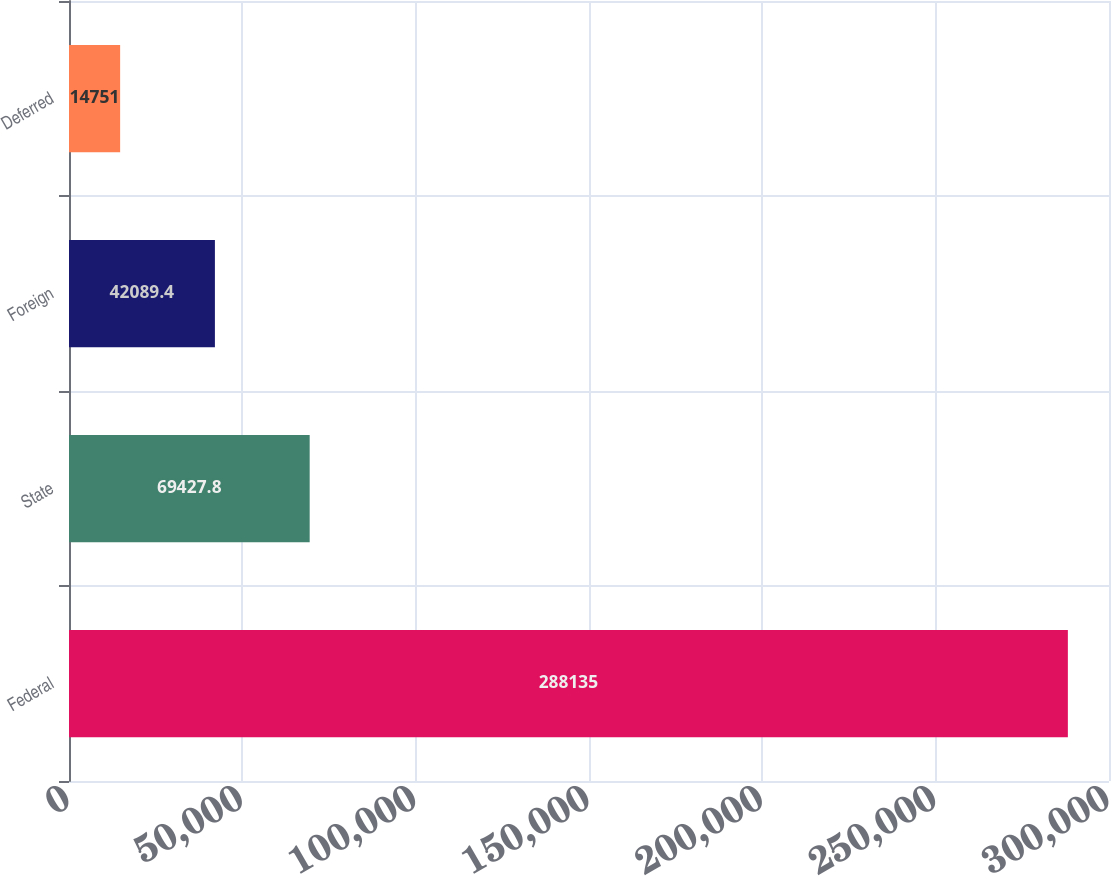Convert chart. <chart><loc_0><loc_0><loc_500><loc_500><bar_chart><fcel>Federal<fcel>State<fcel>Foreign<fcel>Deferred<nl><fcel>288135<fcel>69427.8<fcel>42089.4<fcel>14751<nl></chart> 